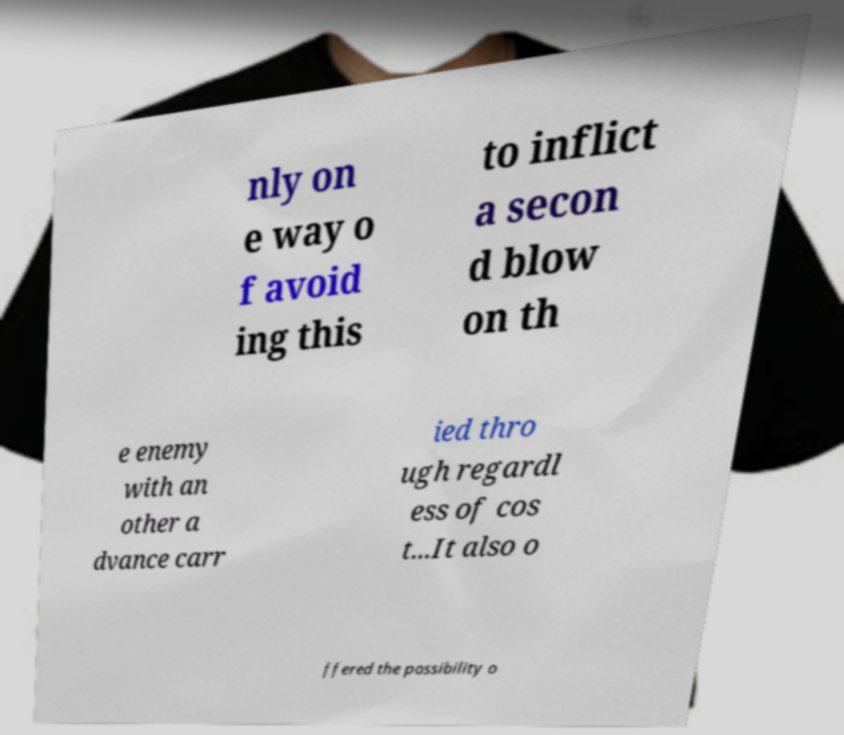Could you extract and type out the text from this image? nly on e way o f avoid ing this to inflict a secon d blow on th e enemy with an other a dvance carr ied thro ugh regardl ess of cos t...It also o ffered the possibility o 